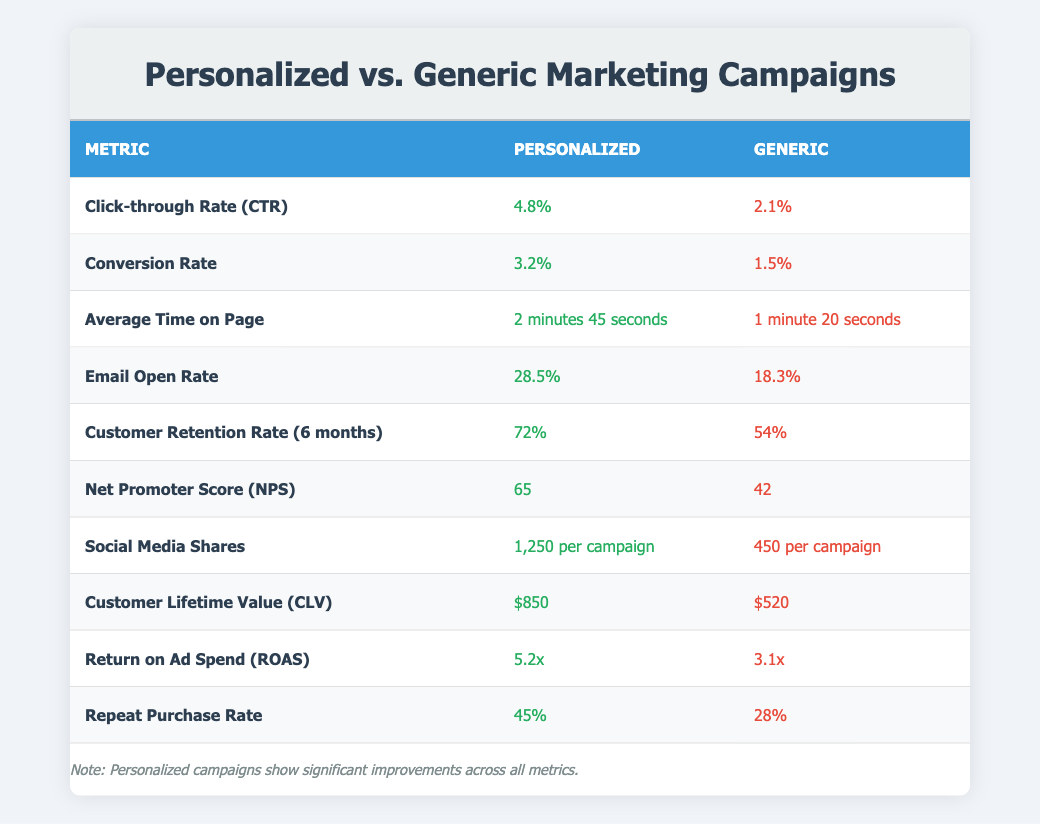What is the Click-through Rate (CTR) for personalized campaigns? The table shows that the Click-through Rate (CTR) for personalized campaigns is listed as 4.8%.
Answer: 4.8% What is the Conversion Rate for generic marketing campaigns? According to the table, the Conversion Rate for generic marketing campaigns is 1.5%.
Answer: 1.5% What is the difference in Customer Retention Rate between personalized and generic campaigns? The Customer Retention Rate for personalized campaigns is 72%, while for generic campaigns it is 54%. The difference is 72% - 54% = 18%.
Answer: 18% Is the Net Promoter Score (NPS) higher for personalized campaigns compared to generic ones? The table presents the NPS as 65 for personalized campaigns and 42 for generic campaigns. Since 65 is greater than 42, the answer is yes.
Answer: Yes How much higher is the Customer Lifetime Value (CLV) for personalized campaigns compared to generic campaigns? The CLV for personalized campaigns is $850 and for generic campaigns, it is $520. To find how much higher, subtract: $850 - $520 = $330.
Answer: $330 What is the average Email Open Rate for personalized and generic campaigns? The Email Open Rate for personalized campaigns is 28.5% and for generic campaigns, it is 18.3%. To find the average, sum these rates and divide by 2: (28.5 + 18.3) / 2 = 23.4%.
Answer: 23.4% How many Social Media Shares per campaign does a personalized campaign achieve compared to a generic one? Personalized campaigns achieve 1,250 Social Media Shares per campaign, whereas generic campaigns achieve 450. To find the difference: 1,250 - 450 = 800.
Answer: 800 Which campaign type has a higher Return on Ad Spend (ROAS), and by how much? The ROAS for personalized campaigns is 5.2x and for generic campaigns is 3.1x. The difference in ROAS is 5.2 - 3.1 = 2.1.
Answer: 2.1 Does personalized marketing have a higher Repeat Purchase Rate than generic marketing? The Repeat Purchase Rate for personalized marketing is 45% compared to 28% for generic marketing. Since 45% is greater than 28%, the answer is yes.
Answer: Yes 